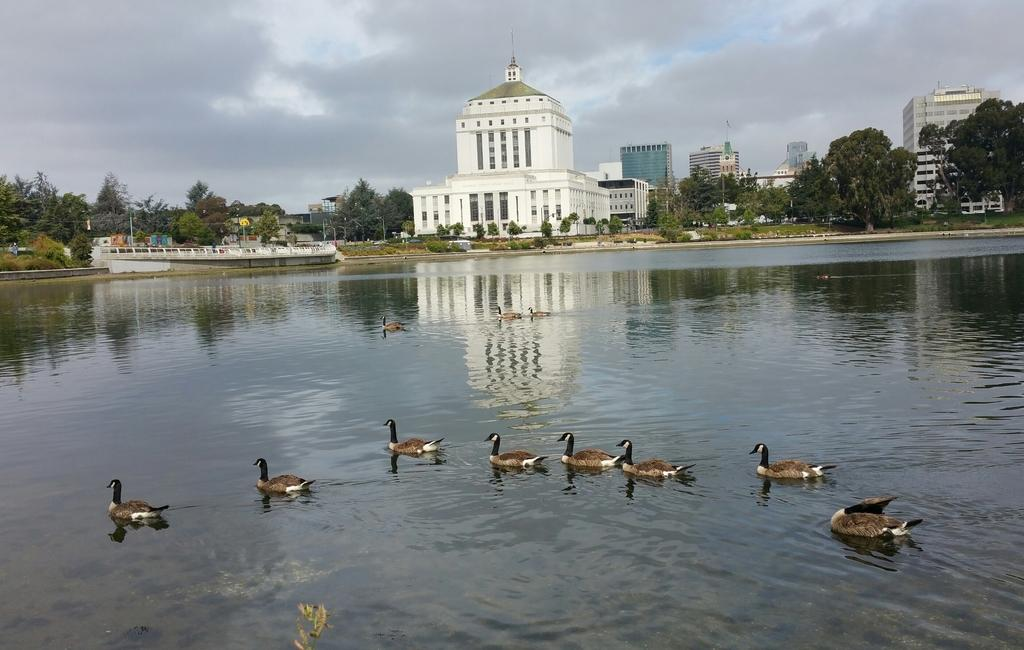What type of animals can be seen in the image? There are ducks in the water. What is visible in the background of the image? There is a boat, buildings, and trees in the background. What is the condition of the sky in the image? The sky is cloudy in the image. Where is the volleyball court located in the image? There is no volleyball court present in the image. What type of attraction can be seen in the image? There is no specific attraction mentioned in the image; it features ducks in the water, a boat, buildings, trees, and a cloudy sky. 